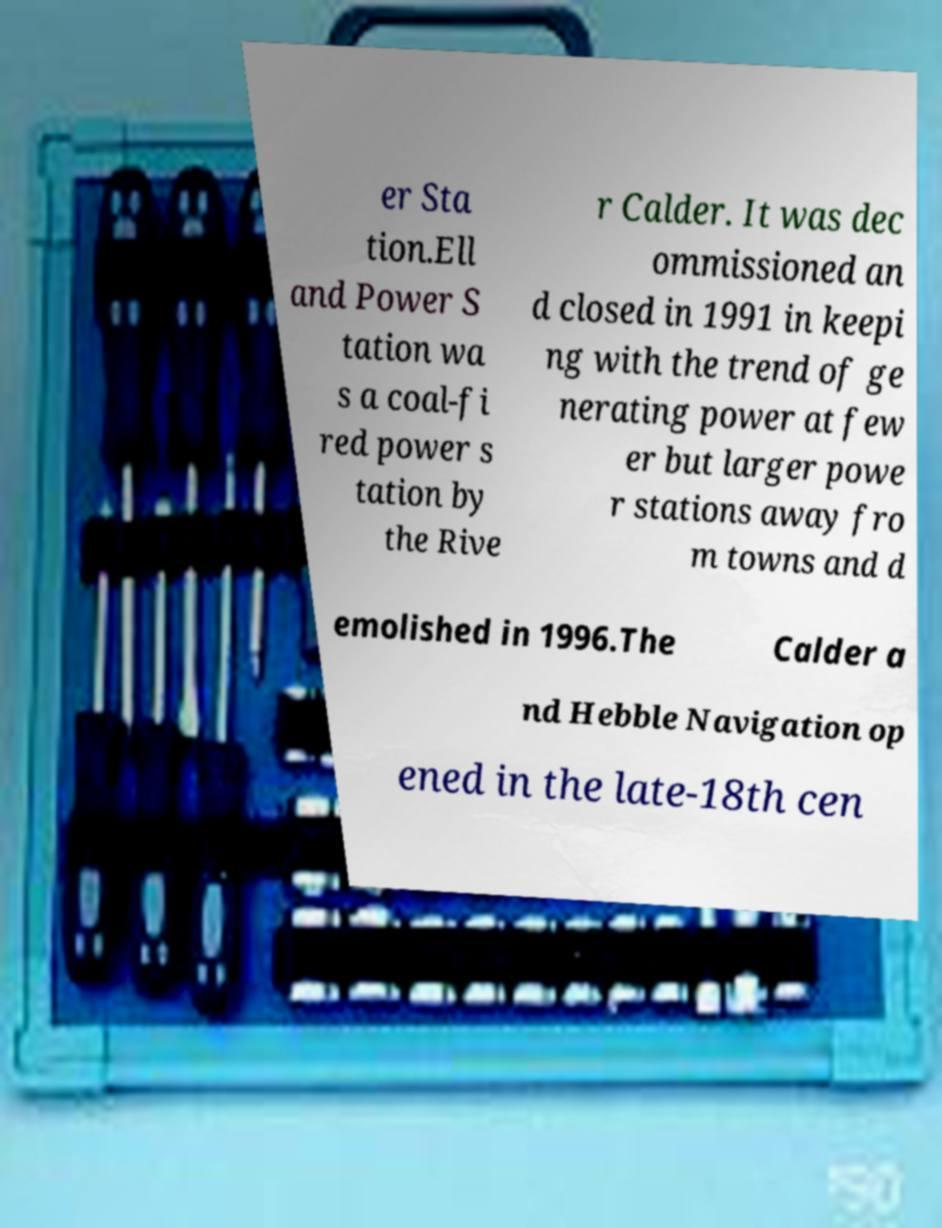Could you assist in decoding the text presented in this image and type it out clearly? er Sta tion.Ell and Power S tation wa s a coal-fi red power s tation by the Rive r Calder. It was dec ommissioned an d closed in 1991 in keepi ng with the trend of ge nerating power at few er but larger powe r stations away fro m towns and d emolished in 1996.The Calder a nd Hebble Navigation op ened in the late-18th cen 